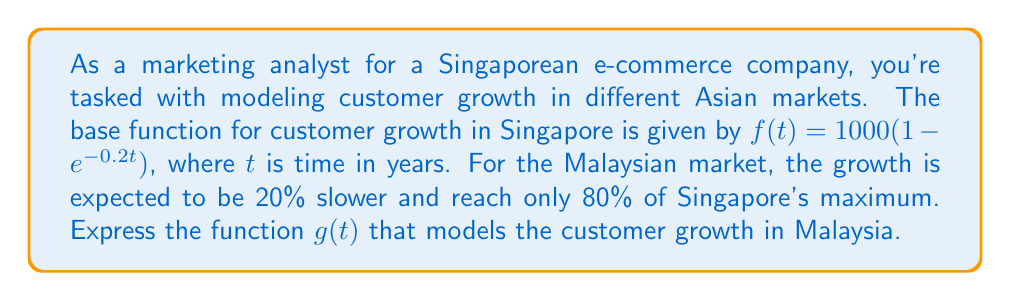Solve this math problem. To transform the base function $f(t)$ into $g(t)$ for the Malaysian market, we need to apply two transformations:

1. Slow down the growth by 20%:
   This means stretching the function horizontally by a factor of $\frac{1}{0.8} = 1.25$.
   Replace $t$ with $\frac{t}{1.25}$ in the original function.

2. Reduce the maximum by 20%:
   This means vertically scaling the function by a factor of 0.8.
   Multiply the entire function by 0.8.

Step-by-step transformation:

1. Start with $f(t) = 1000(1 - e^{-0.2t})$

2. Replace $t$ with $\frac{t}{1.25}$:
   $f(\frac{t}{1.25}) = 1000(1 - e^{-0.2(\frac{t}{1.25})})$

3. Simplify the exponent:
   $f(\frac{t}{1.25}) = 1000(1 - e^{-0.16t})$

4. Multiply by 0.8 to get $g(t)$:
   $g(t) = 0.8 \cdot 1000(1 - e^{-0.16t})$

5. Simplify:
   $g(t) = 800(1 - e^{-0.16t})$

Therefore, the function $g(t)$ that models the customer growth in Malaysia is:

$$g(t) = 800(1 - e^{-0.16t})$$
Answer: $g(t) = 800(1 - e^{-0.16t})$ 